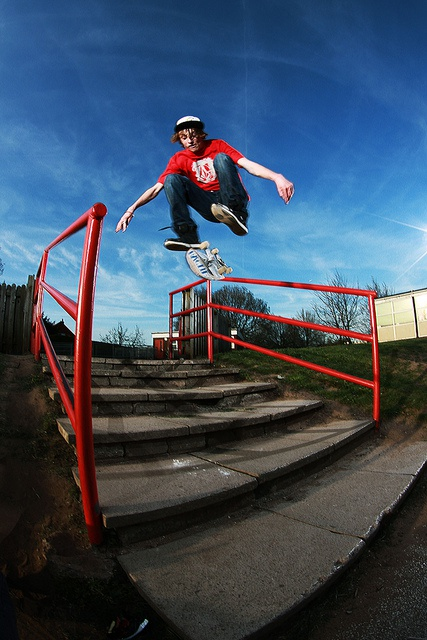Describe the objects in this image and their specific colors. I can see people in blue, black, lightgray, red, and maroon tones and skateboard in blue, lightgray, darkgray, gray, and tan tones in this image. 